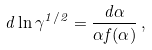<formula> <loc_0><loc_0><loc_500><loc_500>d \ln \gamma ^ { 1 / 2 } = \frac { d \alpha } { \alpha f ( \alpha ) } \, ,</formula> 